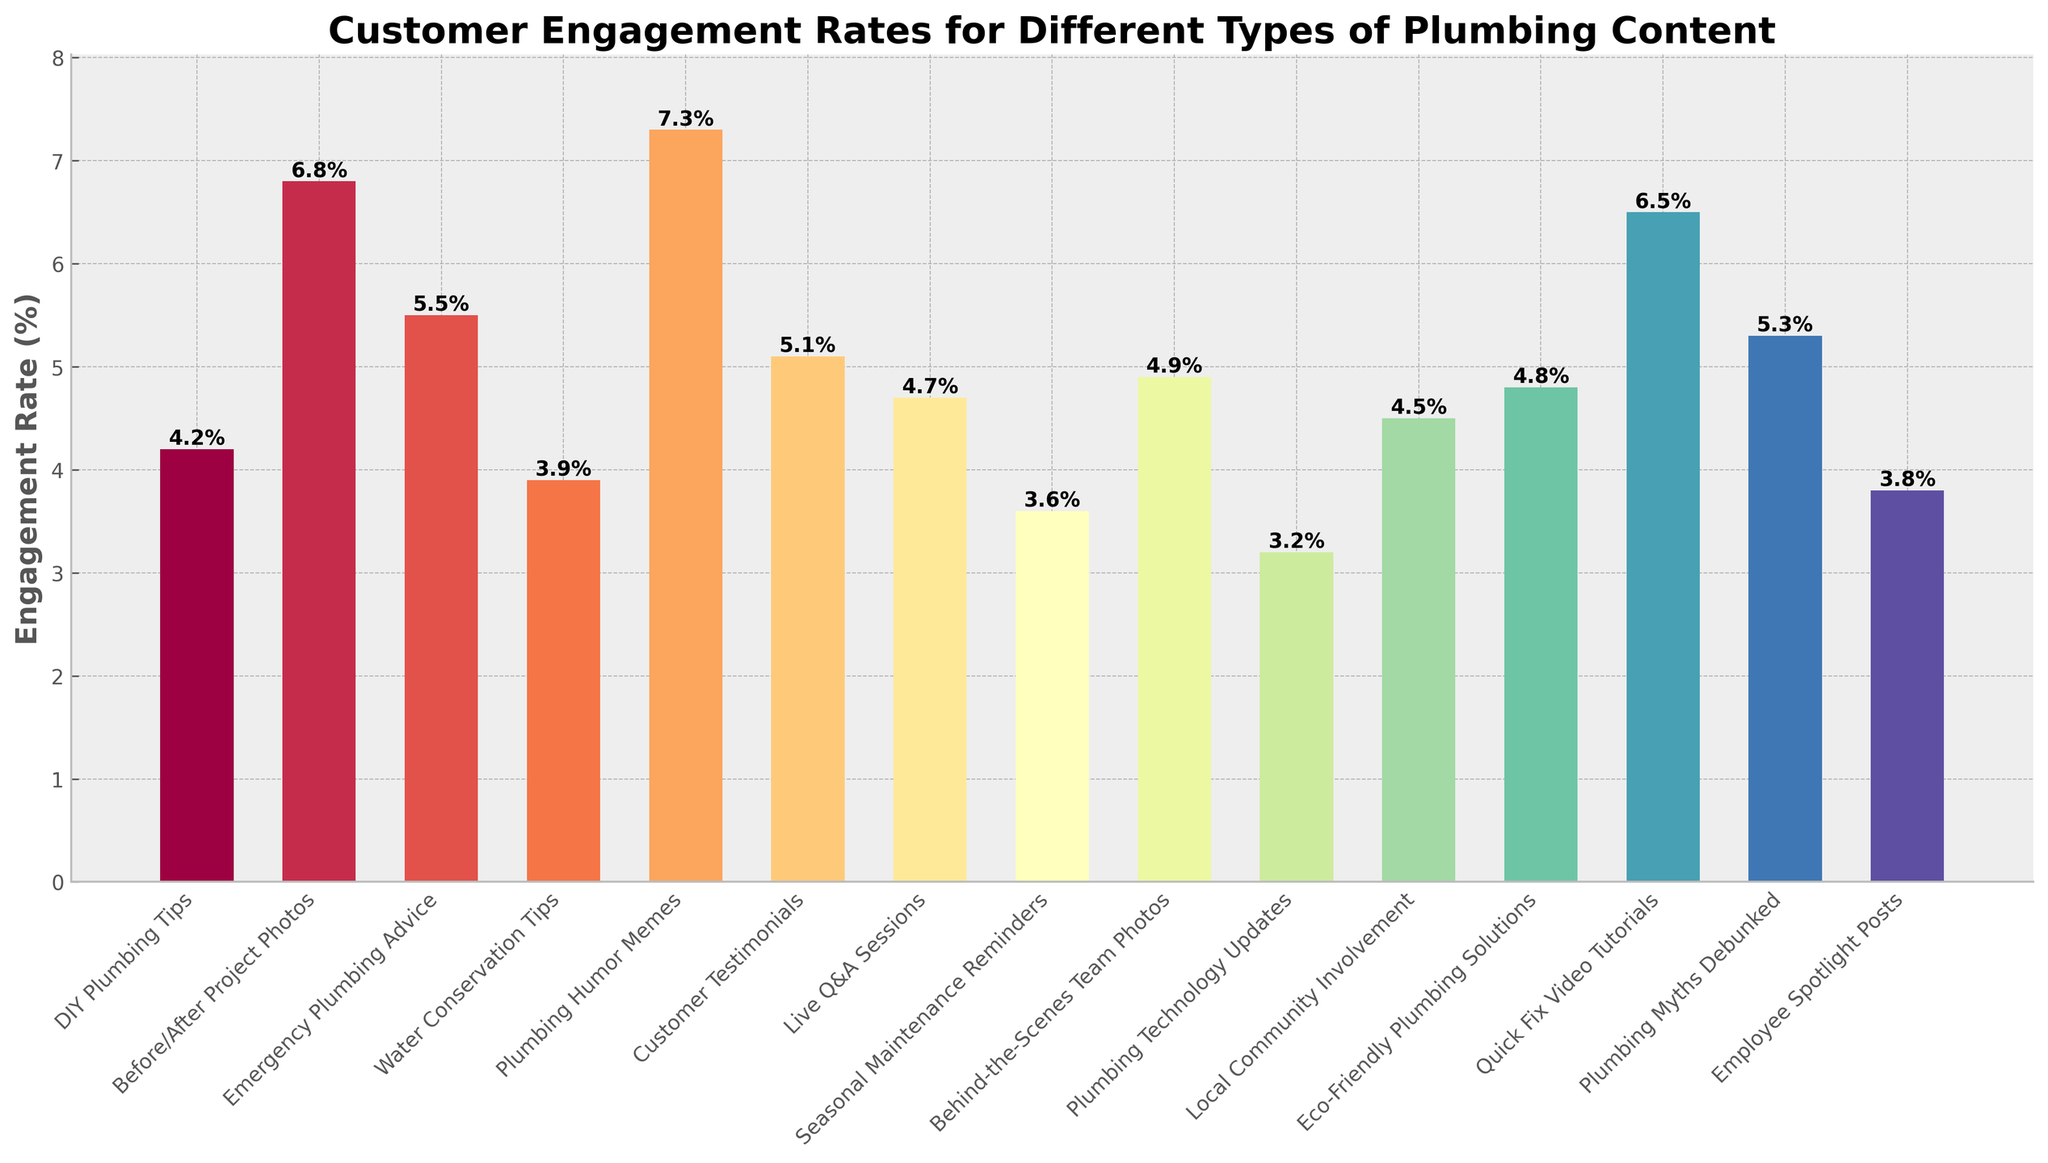Which type of plumbing content has the highest engagement rate? By observing the highest bar on the chart, we can see that "Plumbing Humor Memes" has the highest engagement rate at 7.3%.
Answer: Plumbing Humor Memes How much higher is the engagement rate for "Before/After Project Photos" compared to "DIY Plumbing Tips"? "Before/After Project Photos" has an engagement rate of 6.8%, and "DIY Plumbing Tips" has 4.2%. The difference is 6.8% - 4.2% = 2.6%.
Answer: 2.6% Which content type has a lower engagement rate: "Emergency Plumbing Advice" or "Customer Testimonials"? Comparing the bars for "Emergency Plumbing Advice" (5.5%) and "Customer Testimonials" (5.1%), we see that "Customer Testimonials" has a lower engagement rate.
Answer: Customer Testimonials What is the average engagement rate for all content types? Summing all the engagement rates: 4.2 + 6.8 + 5.5 + 3.9 + 7.3 + 5.1 + 4.7 + 3.6 + 4.9 + 3.2 + 4.5 + 4.8 + 6.5 + 5.3 + 3.8 = 74.1. The number of content types is 15. So, the average is 74.1 / 15 = 4.94.
Answer: 4.94 What is the engagement rate difference between the content types with the highest and lowest values? The highest engagement rate is for "Plumbing Humor Memes" at 7.3%, and the lowest is for "Plumbing Technology Updates" at 3.2%. The difference is 7.3% - 3.2% = 4.1%.
Answer: 4.1% Which content type has a greater engagement rate: "Seasonal Maintenance Reminders" or "Live Q&A Sessions"? Observing the chart, "Live Q&A Sessions" has an engagement rate of 4.7%, while "Seasonal Maintenance Reminders" has 3.6%. So, "Live Q&A Sessions" has a greater rate.
Answer: Live Q&A Sessions What's the total engagement rate for all content types related to eco-friendliness and water conservation? Adding the rates for "Water Conservation Tips" (3.9%) and "Eco-Friendly Plumbing Solutions" (4.8%) yields 3.9% + 4.8% = 8.7%.
Answer: 8.7% How many content types have an engagement rate higher than 5%? By counting the bars with heights greater than 5%: "Before/After Project Photos" (6.8%), "Emergency Plumbing Advice" (5.5%), "Plumbing Humor Memes" (7.3%), "Customer Testimonials" (5.1%), and "Quick Fix Video Tutorials" (6.5%) and, "Plumbing Myths Debunked" (5.3%). There are 6 such content types.
Answer: 6 Compare the engagement rate for "Employee Spotlight Posts" with the average engagement rate? "Employee Spotlight Posts" has an engagement rate of 3.8%. The average rate for all content types is 4.94%. So, "Employee Spotlight Posts" is lower than the average by 4.94% - 3.8% = 1.14%.
Answer: Lower by 1.14% 